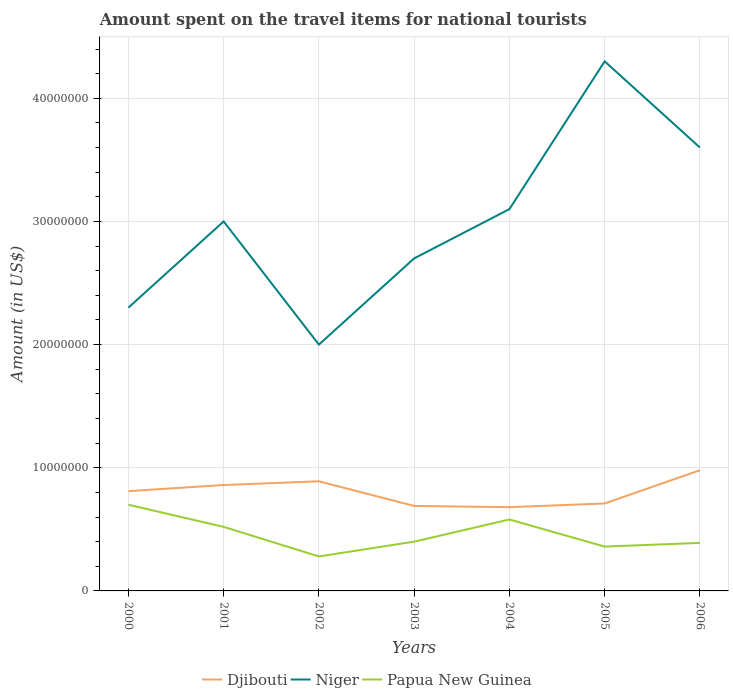Is the number of lines equal to the number of legend labels?
Give a very brief answer. Yes. In which year was the amount spent on the travel items for national tourists in Djibouti maximum?
Provide a short and direct response. 2004. What is the total amount spent on the travel items for national tourists in Djibouti in the graph?
Your response must be concise. -2.00e+05. What is the difference between the highest and the second highest amount spent on the travel items for national tourists in Djibouti?
Provide a short and direct response. 3.00e+06. What is the difference between the highest and the lowest amount spent on the travel items for national tourists in Niger?
Offer a very short reply. 3. How many lines are there?
Make the answer very short. 3. Does the graph contain any zero values?
Your response must be concise. No. Does the graph contain grids?
Provide a short and direct response. Yes. Where does the legend appear in the graph?
Offer a terse response. Bottom center. How are the legend labels stacked?
Your answer should be compact. Horizontal. What is the title of the graph?
Give a very brief answer. Amount spent on the travel items for national tourists. Does "Dominican Republic" appear as one of the legend labels in the graph?
Provide a short and direct response. No. What is the label or title of the X-axis?
Give a very brief answer. Years. What is the Amount (in US$) in Djibouti in 2000?
Provide a short and direct response. 8.10e+06. What is the Amount (in US$) of Niger in 2000?
Your response must be concise. 2.30e+07. What is the Amount (in US$) in Papua New Guinea in 2000?
Your answer should be very brief. 7.00e+06. What is the Amount (in US$) of Djibouti in 2001?
Ensure brevity in your answer.  8.60e+06. What is the Amount (in US$) in Niger in 2001?
Ensure brevity in your answer.  3.00e+07. What is the Amount (in US$) in Papua New Guinea in 2001?
Give a very brief answer. 5.20e+06. What is the Amount (in US$) of Djibouti in 2002?
Offer a very short reply. 8.90e+06. What is the Amount (in US$) of Niger in 2002?
Make the answer very short. 2.00e+07. What is the Amount (in US$) in Papua New Guinea in 2002?
Provide a succinct answer. 2.80e+06. What is the Amount (in US$) of Djibouti in 2003?
Make the answer very short. 6.90e+06. What is the Amount (in US$) in Niger in 2003?
Your answer should be very brief. 2.70e+07. What is the Amount (in US$) in Papua New Guinea in 2003?
Provide a short and direct response. 4.00e+06. What is the Amount (in US$) in Djibouti in 2004?
Keep it short and to the point. 6.80e+06. What is the Amount (in US$) of Niger in 2004?
Give a very brief answer. 3.10e+07. What is the Amount (in US$) in Papua New Guinea in 2004?
Your answer should be very brief. 5.80e+06. What is the Amount (in US$) of Djibouti in 2005?
Make the answer very short. 7.10e+06. What is the Amount (in US$) of Niger in 2005?
Make the answer very short. 4.30e+07. What is the Amount (in US$) in Papua New Guinea in 2005?
Give a very brief answer. 3.60e+06. What is the Amount (in US$) in Djibouti in 2006?
Your response must be concise. 9.80e+06. What is the Amount (in US$) in Niger in 2006?
Ensure brevity in your answer.  3.60e+07. What is the Amount (in US$) in Papua New Guinea in 2006?
Your response must be concise. 3.90e+06. Across all years, what is the maximum Amount (in US$) in Djibouti?
Offer a terse response. 9.80e+06. Across all years, what is the maximum Amount (in US$) of Niger?
Keep it short and to the point. 4.30e+07. Across all years, what is the minimum Amount (in US$) of Djibouti?
Your answer should be very brief. 6.80e+06. Across all years, what is the minimum Amount (in US$) in Niger?
Your answer should be compact. 2.00e+07. Across all years, what is the minimum Amount (in US$) in Papua New Guinea?
Ensure brevity in your answer.  2.80e+06. What is the total Amount (in US$) of Djibouti in the graph?
Your response must be concise. 5.62e+07. What is the total Amount (in US$) in Niger in the graph?
Offer a terse response. 2.10e+08. What is the total Amount (in US$) of Papua New Guinea in the graph?
Ensure brevity in your answer.  3.23e+07. What is the difference between the Amount (in US$) in Djibouti in 2000 and that in 2001?
Offer a very short reply. -5.00e+05. What is the difference between the Amount (in US$) of Niger in 2000 and that in 2001?
Your answer should be very brief. -7.00e+06. What is the difference between the Amount (in US$) in Papua New Guinea in 2000 and that in 2001?
Give a very brief answer. 1.80e+06. What is the difference between the Amount (in US$) of Djibouti in 2000 and that in 2002?
Keep it short and to the point. -8.00e+05. What is the difference between the Amount (in US$) in Papua New Guinea in 2000 and that in 2002?
Offer a terse response. 4.20e+06. What is the difference between the Amount (in US$) of Djibouti in 2000 and that in 2003?
Keep it short and to the point. 1.20e+06. What is the difference between the Amount (in US$) in Niger in 2000 and that in 2003?
Keep it short and to the point. -4.00e+06. What is the difference between the Amount (in US$) of Papua New Guinea in 2000 and that in 2003?
Offer a very short reply. 3.00e+06. What is the difference between the Amount (in US$) in Djibouti in 2000 and that in 2004?
Give a very brief answer. 1.30e+06. What is the difference between the Amount (in US$) in Niger in 2000 and that in 2004?
Your answer should be very brief. -8.00e+06. What is the difference between the Amount (in US$) of Papua New Guinea in 2000 and that in 2004?
Make the answer very short. 1.20e+06. What is the difference between the Amount (in US$) in Niger in 2000 and that in 2005?
Offer a very short reply. -2.00e+07. What is the difference between the Amount (in US$) in Papua New Guinea in 2000 and that in 2005?
Provide a succinct answer. 3.40e+06. What is the difference between the Amount (in US$) in Djibouti in 2000 and that in 2006?
Offer a terse response. -1.70e+06. What is the difference between the Amount (in US$) in Niger in 2000 and that in 2006?
Your response must be concise. -1.30e+07. What is the difference between the Amount (in US$) in Papua New Guinea in 2000 and that in 2006?
Ensure brevity in your answer.  3.10e+06. What is the difference between the Amount (in US$) in Papua New Guinea in 2001 and that in 2002?
Offer a terse response. 2.40e+06. What is the difference between the Amount (in US$) in Djibouti in 2001 and that in 2003?
Provide a succinct answer. 1.70e+06. What is the difference between the Amount (in US$) of Papua New Guinea in 2001 and that in 2003?
Offer a terse response. 1.20e+06. What is the difference between the Amount (in US$) in Djibouti in 2001 and that in 2004?
Offer a terse response. 1.80e+06. What is the difference between the Amount (in US$) in Niger in 2001 and that in 2004?
Keep it short and to the point. -1.00e+06. What is the difference between the Amount (in US$) in Papua New Guinea in 2001 and that in 2004?
Provide a short and direct response. -6.00e+05. What is the difference between the Amount (in US$) in Djibouti in 2001 and that in 2005?
Provide a short and direct response. 1.50e+06. What is the difference between the Amount (in US$) in Niger in 2001 and that in 2005?
Provide a short and direct response. -1.30e+07. What is the difference between the Amount (in US$) in Papua New Guinea in 2001 and that in 2005?
Provide a short and direct response. 1.60e+06. What is the difference between the Amount (in US$) of Djibouti in 2001 and that in 2006?
Make the answer very short. -1.20e+06. What is the difference between the Amount (in US$) in Niger in 2001 and that in 2006?
Ensure brevity in your answer.  -6.00e+06. What is the difference between the Amount (in US$) of Papua New Guinea in 2001 and that in 2006?
Ensure brevity in your answer.  1.30e+06. What is the difference between the Amount (in US$) in Djibouti in 2002 and that in 2003?
Provide a short and direct response. 2.00e+06. What is the difference between the Amount (in US$) of Niger in 2002 and that in 2003?
Keep it short and to the point. -7.00e+06. What is the difference between the Amount (in US$) of Papua New Guinea in 2002 and that in 2003?
Your answer should be very brief. -1.20e+06. What is the difference between the Amount (in US$) of Djibouti in 2002 and that in 2004?
Your response must be concise. 2.10e+06. What is the difference between the Amount (in US$) in Niger in 2002 and that in 2004?
Your answer should be very brief. -1.10e+07. What is the difference between the Amount (in US$) of Papua New Guinea in 2002 and that in 2004?
Provide a succinct answer. -3.00e+06. What is the difference between the Amount (in US$) of Djibouti in 2002 and that in 2005?
Your answer should be compact. 1.80e+06. What is the difference between the Amount (in US$) of Niger in 2002 and that in 2005?
Give a very brief answer. -2.30e+07. What is the difference between the Amount (in US$) of Papua New Guinea in 2002 and that in 2005?
Offer a terse response. -8.00e+05. What is the difference between the Amount (in US$) in Djibouti in 2002 and that in 2006?
Provide a succinct answer. -9.00e+05. What is the difference between the Amount (in US$) of Niger in 2002 and that in 2006?
Provide a succinct answer. -1.60e+07. What is the difference between the Amount (in US$) of Papua New Guinea in 2002 and that in 2006?
Ensure brevity in your answer.  -1.10e+06. What is the difference between the Amount (in US$) of Djibouti in 2003 and that in 2004?
Provide a succinct answer. 1.00e+05. What is the difference between the Amount (in US$) of Niger in 2003 and that in 2004?
Keep it short and to the point. -4.00e+06. What is the difference between the Amount (in US$) of Papua New Guinea in 2003 and that in 2004?
Ensure brevity in your answer.  -1.80e+06. What is the difference between the Amount (in US$) in Djibouti in 2003 and that in 2005?
Your answer should be compact. -2.00e+05. What is the difference between the Amount (in US$) of Niger in 2003 and that in 2005?
Provide a short and direct response. -1.60e+07. What is the difference between the Amount (in US$) in Papua New Guinea in 2003 and that in 2005?
Provide a short and direct response. 4.00e+05. What is the difference between the Amount (in US$) of Djibouti in 2003 and that in 2006?
Ensure brevity in your answer.  -2.90e+06. What is the difference between the Amount (in US$) of Niger in 2003 and that in 2006?
Your response must be concise. -9.00e+06. What is the difference between the Amount (in US$) in Papua New Guinea in 2003 and that in 2006?
Provide a succinct answer. 1.00e+05. What is the difference between the Amount (in US$) in Djibouti in 2004 and that in 2005?
Ensure brevity in your answer.  -3.00e+05. What is the difference between the Amount (in US$) of Niger in 2004 and that in 2005?
Ensure brevity in your answer.  -1.20e+07. What is the difference between the Amount (in US$) of Papua New Guinea in 2004 and that in 2005?
Make the answer very short. 2.20e+06. What is the difference between the Amount (in US$) of Niger in 2004 and that in 2006?
Your response must be concise. -5.00e+06. What is the difference between the Amount (in US$) in Papua New Guinea in 2004 and that in 2006?
Your answer should be very brief. 1.90e+06. What is the difference between the Amount (in US$) in Djibouti in 2005 and that in 2006?
Give a very brief answer. -2.70e+06. What is the difference between the Amount (in US$) of Djibouti in 2000 and the Amount (in US$) of Niger in 2001?
Ensure brevity in your answer.  -2.19e+07. What is the difference between the Amount (in US$) in Djibouti in 2000 and the Amount (in US$) in Papua New Guinea in 2001?
Your answer should be very brief. 2.90e+06. What is the difference between the Amount (in US$) in Niger in 2000 and the Amount (in US$) in Papua New Guinea in 2001?
Your answer should be compact. 1.78e+07. What is the difference between the Amount (in US$) of Djibouti in 2000 and the Amount (in US$) of Niger in 2002?
Keep it short and to the point. -1.19e+07. What is the difference between the Amount (in US$) in Djibouti in 2000 and the Amount (in US$) in Papua New Guinea in 2002?
Your answer should be very brief. 5.30e+06. What is the difference between the Amount (in US$) of Niger in 2000 and the Amount (in US$) of Papua New Guinea in 2002?
Ensure brevity in your answer.  2.02e+07. What is the difference between the Amount (in US$) in Djibouti in 2000 and the Amount (in US$) in Niger in 2003?
Give a very brief answer. -1.89e+07. What is the difference between the Amount (in US$) of Djibouti in 2000 and the Amount (in US$) of Papua New Guinea in 2003?
Your answer should be compact. 4.10e+06. What is the difference between the Amount (in US$) in Niger in 2000 and the Amount (in US$) in Papua New Guinea in 2003?
Keep it short and to the point. 1.90e+07. What is the difference between the Amount (in US$) in Djibouti in 2000 and the Amount (in US$) in Niger in 2004?
Your answer should be very brief. -2.29e+07. What is the difference between the Amount (in US$) in Djibouti in 2000 and the Amount (in US$) in Papua New Guinea in 2004?
Your answer should be compact. 2.30e+06. What is the difference between the Amount (in US$) in Niger in 2000 and the Amount (in US$) in Papua New Guinea in 2004?
Offer a very short reply. 1.72e+07. What is the difference between the Amount (in US$) of Djibouti in 2000 and the Amount (in US$) of Niger in 2005?
Your response must be concise. -3.49e+07. What is the difference between the Amount (in US$) of Djibouti in 2000 and the Amount (in US$) of Papua New Guinea in 2005?
Offer a very short reply. 4.50e+06. What is the difference between the Amount (in US$) of Niger in 2000 and the Amount (in US$) of Papua New Guinea in 2005?
Provide a short and direct response. 1.94e+07. What is the difference between the Amount (in US$) of Djibouti in 2000 and the Amount (in US$) of Niger in 2006?
Ensure brevity in your answer.  -2.79e+07. What is the difference between the Amount (in US$) in Djibouti in 2000 and the Amount (in US$) in Papua New Guinea in 2006?
Provide a short and direct response. 4.20e+06. What is the difference between the Amount (in US$) in Niger in 2000 and the Amount (in US$) in Papua New Guinea in 2006?
Give a very brief answer. 1.91e+07. What is the difference between the Amount (in US$) in Djibouti in 2001 and the Amount (in US$) in Niger in 2002?
Make the answer very short. -1.14e+07. What is the difference between the Amount (in US$) in Djibouti in 2001 and the Amount (in US$) in Papua New Guinea in 2002?
Your answer should be very brief. 5.80e+06. What is the difference between the Amount (in US$) of Niger in 2001 and the Amount (in US$) of Papua New Guinea in 2002?
Offer a terse response. 2.72e+07. What is the difference between the Amount (in US$) of Djibouti in 2001 and the Amount (in US$) of Niger in 2003?
Make the answer very short. -1.84e+07. What is the difference between the Amount (in US$) of Djibouti in 2001 and the Amount (in US$) of Papua New Guinea in 2003?
Your response must be concise. 4.60e+06. What is the difference between the Amount (in US$) of Niger in 2001 and the Amount (in US$) of Papua New Guinea in 2003?
Offer a very short reply. 2.60e+07. What is the difference between the Amount (in US$) of Djibouti in 2001 and the Amount (in US$) of Niger in 2004?
Offer a terse response. -2.24e+07. What is the difference between the Amount (in US$) of Djibouti in 2001 and the Amount (in US$) of Papua New Guinea in 2004?
Make the answer very short. 2.80e+06. What is the difference between the Amount (in US$) in Niger in 2001 and the Amount (in US$) in Papua New Guinea in 2004?
Your answer should be very brief. 2.42e+07. What is the difference between the Amount (in US$) in Djibouti in 2001 and the Amount (in US$) in Niger in 2005?
Keep it short and to the point. -3.44e+07. What is the difference between the Amount (in US$) in Niger in 2001 and the Amount (in US$) in Papua New Guinea in 2005?
Provide a short and direct response. 2.64e+07. What is the difference between the Amount (in US$) in Djibouti in 2001 and the Amount (in US$) in Niger in 2006?
Offer a terse response. -2.74e+07. What is the difference between the Amount (in US$) of Djibouti in 2001 and the Amount (in US$) of Papua New Guinea in 2006?
Your answer should be compact. 4.70e+06. What is the difference between the Amount (in US$) of Niger in 2001 and the Amount (in US$) of Papua New Guinea in 2006?
Make the answer very short. 2.61e+07. What is the difference between the Amount (in US$) of Djibouti in 2002 and the Amount (in US$) of Niger in 2003?
Make the answer very short. -1.81e+07. What is the difference between the Amount (in US$) of Djibouti in 2002 and the Amount (in US$) of Papua New Guinea in 2003?
Ensure brevity in your answer.  4.90e+06. What is the difference between the Amount (in US$) in Niger in 2002 and the Amount (in US$) in Papua New Guinea in 2003?
Your answer should be compact. 1.60e+07. What is the difference between the Amount (in US$) of Djibouti in 2002 and the Amount (in US$) of Niger in 2004?
Offer a very short reply. -2.21e+07. What is the difference between the Amount (in US$) of Djibouti in 2002 and the Amount (in US$) of Papua New Guinea in 2004?
Keep it short and to the point. 3.10e+06. What is the difference between the Amount (in US$) of Niger in 2002 and the Amount (in US$) of Papua New Guinea in 2004?
Your answer should be compact. 1.42e+07. What is the difference between the Amount (in US$) of Djibouti in 2002 and the Amount (in US$) of Niger in 2005?
Provide a succinct answer. -3.41e+07. What is the difference between the Amount (in US$) of Djibouti in 2002 and the Amount (in US$) of Papua New Guinea in 2005?
Provide a short and direct response. 5.30e+06. What is the difference between the Amount (in US$) in Niger in 2002 and the Amount (in US$) in Papua New Guinea in 2005?
Provide a succinct answer. 1.64e+07. What is the difference between the Amount (in US$) of Djibouti in 2002 and the Amount (in US$) of Niger in 2006?
Keep it short and to the point. -2.71e+07. What is the difference between the Amount (in US$) in Djibouti in 2002 and the Amount (in US$) in Papua New Guinea in 2006?
Provide a short and direct response. 5.00e+06. What is the difference between the Amount (in US$) in Niger in 2002 and the Amount (in US$) in Papua New Guinea in 2006?
Offer a terse response. 1.61e+07. What is the difference between the Amount (in US$) of Djibouti in 2003 and the Amount (in US$) of Niger in 2004?
Your answer should be compact. -2.41e+07. What is the difference between the Amount (in US$) in Djibouti in 2003 and the Amount (in US$) in Papua New Guinea in 2004?
Your answer should be compact. 1.10e+06. What is the difference between the Amount (in US$) of Niger in 2003 and the Amount (in US$) of Papua New Guinea in 2004?
Ensure brevity in your answer.  2.12e+07. What is the difference between the Amount (in US$) of Djibouti in 2003 and the Amount (in US$) of Niger in 2005?
Your answer should be very brief. -3.61e+07. What is the difference between the Amount (in US$) in Djibouti in 2003 and the Amount (in US$) in Papua New Guinea in 2005?
Provide a short and direct response. 3.30e+06. What is the difference between the Amount (in US$) of Niger in 2003 and the Amount (in US$) of Papua New Guinea in 2005?
Give a very brief answer. 2.34e+07. What is the difference between the Amount (in US$) in Djibouti in 2003 and the Amount (in US$) in Niger in 2006?
Offer a very short reply. -2.91e+07. What is the difference between the Amount (in US$) in Niger in 2003 and the Amount (in US$) in Papua New Guinea in 2006?
Offer a terse response. 2.31e+07. What is the difference between the Amount (in US$) in Djibouti in 2004 and the Amount (in US$) in Niger in 2005?
Offer a terse response. -3.62e+07. What is the difference between the Amount (in US$) of Djibouti in 2004 and the Amount (in US$) of Papua New Guinea in 2005?
Your answer should be compact. 3.20e+06. What is the difference between the Amount (in US$) in Niger in 2004 and the Amount (in US$) in Papua New Guinea in 2005?
Your answer should be very brief. 2.74e+07. What is the difference between the Amount (in US$) in Djibouti in 2004 and the Amount (in US$) in Niger in 2006?
Your answer should be compact. -2.92e+07. What is the difference between the Amount (in US$) of Djibouti in 2004 and the Amount (in US$) of Papua New Guinea in 2006?
Ensure brevity in your answer.  2.90e+06. What is the difference between the Amount (in US$) of Niger in 2004 and the Amount (in US$) of Papua New Guinea in 2006?
Offer a terse response. 2.71e+07. What is the difference between the Amount (in US$) in Djibouti in 2005 and the Amount (in US$) in Niger in 2006?
Provide a succinct answer. -2.89e+07. What is the difference between the Amount (in US$) of Djibouti in 2005 and the Amount (in US$) of Papua New Guinea in 2006?
Make the answer very short. 3.20e+06. What is the difference between the Amount (in US$) of Niger in 2005 and the Amount (in US$) of Papua New Guinea in 2006?
Provide a short and direct response. 3.91e+07. What is the average Amount (in US$) of Djibouti per year?
Keep it short and to the point. 8.03e+06. What is the average Amount (in US$) of Niger per year?
Offer a terse response. 3.00e+07. What is the average Amount (in US$) of Papua New Guinea per year?
Provide a succinct answer. 4.61e+06. In the year 2000, what is the difference between the Amount (in US$) of Djibouti and Amount (in US$) of Niger?
Keep it short and to the point. -1.49e+07. In the year 2000, what is the difference between the Amount (in US$) in Djibouti and Amount (in US$) in Papua New Guinea?
Offer a very short reply. 1.10e+06. In the year 2000, what is the difference between the Amount (in US$) in Niger and Amount (in US$) in Papua New Guinea?
Offer a very short reply. 1.60e+07. In the year 2001, what is the difference between the Amount (in US$) of Djibouti and Amount (in US$) of Niger?
Ensure brevity in your answer.  -2.14e+07. In the year 2001, what is the difference between the Amount (in US$) in Djibouti and Amount (in US$) in Papua New Guinea?
Provide a short and direct response. 3.40e+06. In the year 2001, what is the difference between the Amount (in US$) in Niger and Amount (in US$) in Papua New Guinea?
Offer a terse response. 2.48e+07. In the year 2002, what is the difference between the Amount (in US$) of Djibouti and Amount (in US$) of Niger?
Your answer should be very brief. -1.11e+07. In the year 2002, what is the difference between the Amount (in US$) of Djibouti and Amount (in US$) of Papua New Guinea?
Give a very brief answer. 6.10e+06. In the year 2002, what is the difference between the Amount (in US$) in Niger and Amount (in US$) in Papua New Guinea?
Your response must be concise. 1.72e+07. In the year 2003, what is the difference between the Amount (in US$) of Djibouti and Amount (in US$) of Niger?
Make the answer very short. -2.01e+07. In the year 2003, what is the difference between the Amount (in US$) in Djibouti and Amount (in US$) in Papua New Guinea?
Your response must be concise. 2.90e+06. In the year 2003, what is the difference between the Amount (in US$) in Niger and Amount (in US$) in Papua New Guinea?
Make the answer very short. 2.30e+07. In the year 2004, what is the difference between the Amount (in US$) of Djibouti and Amount (in US$) of Niger?
Make the answer very short. -2.42e+07. In the year 2004, what is the difference between the Amount (in US$) of Djibouti and Amount (in US$) of Papua New Guinea?
Your answer should be compact. 1.00e+06. In the year 2004, what is the difference between the Amount (in US$) of Niger and Amount (in US$) of Papua New Guinea?
Your answer should be compact. 2.52e+07. In the year 2005, what is the difference between the Amount (in US$) in Djibouti and Amount (in US$) in Niger?
Provide a succinct answer. -3.59e+07. In the year 2005, what is the difference between the Amount (in US$) of Djibouti and Amount (in US$) of Papua New Guinea?
Give a very brief answer. 3.50e+06. In the year 2005, what is the difference between the Amount (in US$) in Niger and Amount (in US$) in Papua New Guinea?
Make the answer very short. 3.94e+07. In the year 2006, what is the difference between the Amount (in US$) in Djibouti and Amount (in US$) in Niger?
Offer a terse response. -2.62e+07. In the year 2006, what is the difference between the Amount (in US$) of Djibouti and Amount (in US$) of Papua New Guinea?
Give a very brief answer. 5.90e+06. In the year 2006, what is the difference between the Amount (in US$) in Niger and Amount (in US$) in Papua New Guinea?
Provide a succinct answer. 3.21e+07. What is the ratio of the Amount (in US$) in Djibouti in 2000 to that in 2001?
Ensure brevity in your answer.  0.94. What is the ratio of the Amount (in US$) of Niger in 2000 to that in 2001?
Your response must be concise. 0.77. What is the ratio of the Amount (in US$) of Papua New Guinea in 2000 to that in 2001?
Your answer should be compact. 1.35. What is the ratio of the Amount (in US$) in Djibouti in 2000 to that in 2002?
Offer a terse response. 0.91. What is the ratio of the Amount (in US$) of Niger in 2000 to that in 2002?
Ensure brevity in your answer.  1.15. What is the ratio of the Amount (in US$) in Papua New Guinea in 2000 to that in 2002?
Offer a terse response. 2.5. What is the ratio of the Amount (in US$) in Djibouti in 2000 to that in 2003?
Your answer should be compact. 1.17. What is the ratio of the Amount (in US$) of Niger in 2000 to that in 2003?
Your answer should be compact. 0.85. What is the ratio of the Amount (in US$) of Papua New Guinea in 2000 to that in 2003?
Provide a short and direct response. 1.75. What is the ratio of the Amount (in US$) in Djibouti in 2000 to that in 2004?
Your response must be concise. 1.19. What is the ratio of the Amount (in US$) of Niger in 2000 to that in 2004?
Your response must be concise. 0.74. What is the ratio of the Amount (in US$) in Papua New Guinea in 2000 to that in 2004?
Provide a short and direct response. 1.21. What is the ratio of the Amount (in US$) of Djibouti in 2000 to that in 2005?
Make the answer very short. 1.14. What is the ratio of the Amount (in US$) of Niger in 2000 to that in 2005?
Keep it short and to the point. 0.53. What is the ratio of the Amount (in US$) of Papua New Guinea in 2000 to that in 2005?
Keep it short and to the point. 1.94. What is the ratio of the Amount (in US$) of Djibouti in 2000 to that in 2006?
Ensure brevity in your answer.  0.83. What is the ratio of the Amount (in US$) of Niger in 2000 to that in 2006?
Your answer should be compact. 0.64. What is the ratio of the Amount (in US$) of Papua New Guinea in 2000 to that in 2006?
Offer a terse response. 1.79. What is the ratio of the Amount (in US$) of Djibouti in 2001 to that in 2002?
Keep it short and to the point. 0.97. What is the ratio of the Amount (in US$) of Papua New Guinea in 2001 to that in 2002?
Make the answer very short. 1.86. What is the ratio of the Amount (in US$) of Djibouti in 2001 to that in 2003?
Ensure brevity in your answer.  1.25. What is the ratio of the Amount (in US$) in Niger in 2001 to that in 2003?
Give a very brief answer. 1.11. What is the ratio of the Amount (in US$) in Papua New Guinea in 2001 to that in 2003?
Your answer should be compact. 1.3. What is the ratio of the Amount (in US$) of Djibouti in 2001 to that in 2004?
Keep it short and to the point. 1.26. What is the ratio of the Amount (in US$) in Niger in 2001 to that in 2004?
Give a very brief answer. 0.97. What is the ratio of the Amount (in US$) of Papua New Guinea in 2001 to that in 2004?
Your response must be concise. 0.9. What is the ratio of the Amount (in US$) of Djibouti in 2001 to that in 2005?
Offer a very short reply. 1.21. What is the ratio of the Amount (in US$) of Niger in 2001 to that in 2005?
Offer a very short reply. 0.7. What is the ratio of the Amount (in US$) in Papua New Guinea in 2001 to that in 2005?
Your answer should be very brief. 1.44. What is the ratio of the Amount (in US$) in Djibouti in 2001 to that in 2006?
Provide a succinct answer. 0.88. What is the ratio of the Amount (in US$) of Djibouti in 2002 to that in 2003?
Provide a succinct answer. 1.29. What is the ratio of the Amount (in US$) in Niger in 2002 to that in 2003?
Provide a succinct answer. 0.74. What is the ratio of the Amount (in US$) of Djibouti in 2002 to that in 2004?
Give a very brief answer. 1.31. What is the ratio of the Amount (in US$) in Niger in 2002 to that in 2004?
Your answer should be very brief. 0.65. What is the ratio of the Amount (in US$) of Papua New Guinea in 2002 to that in 2004?
Your answer should be compact. 0.48. What is the ratio of the Amount (in US$) of Djibouti in 2002 to that in 2005?
Make the answer very short. 1.25. What is the ratio of the Amount (in US$) of Niger in 2002 to that in 2005?
Your answer should be very brief. 0.47. What is the ratio of the Amount (in US$) of Papua New Guinea in 2002 to that in 2005?
Provide a succinct answer. 0.78. What is the ratio of the Amount (in US$) of Djibouti in 2002 to that in 2006?
Offer a terse response. 0.91. What is the ratio of the Amount (in US$) in Niger in 2002 to that in 2006?
Make the answer very short. 0.56. What is the ratio of the Amount (in US$) in Papua New Guinea in 2002 to that in 2006?
Your response must be concise. 0.72. What is the ratio of the Amount (in US$) of Djibouti in 2003 to that in 2004?
Offer a very short reply. 1.01. What is the ratio of the Amount (in US$) of Niger in 2003 to that in 2004?
Offer a terse response. 0.87. What is the ratio of the Amount (in US$) of Papua New Guinea in 2003 to that in 2004?
Keep it short and to the point. 0.69. What is the ratio of the Amount (in US$) in Djibouti in 2003 to that in 2005?
Your answer should be compact. 0.97. What is the ratio of the Amount (in US$) in Niger in 2003 to that in 2005?
Provide a succinct answer. 0.63. What is the ratio of the Amount (in US$) of Djibouti in 2003 to that in 2006?
Make the answer very short. 0.7. What is the ratio of the Amount (in US$) of Papua New Guinea in 2003 to that in 2006?
Make the answer very short. 1.03. What is the ratio of the Amount (in US$) of Djibouti in 2004 to that in 2005?
Make the answer very short. 0.96. What is the ratio of the Amount (in US$) of Niger in 2004 to that in 2005?
Offer a very short reply. 0.72. What is the ratio of the Amount (in US$) in Papua New Guinea in 2004 to that in 2005?
Offer a very short reply. 1.61. What is the ratio of the Amount (in US$) of Djibouti in 2004 to that in 2006?
Provide a short and direct response. 0.69. What is the ratio of the Amount (in US$) of Niger in 2004 to that in 2006?
Your answer should be very brief. 0.86. What is the ratio of the Amount (in US$) of Papua New Guinea in 2004 to that in 2006?
Give a very brief answer. 1.49. What is the ratio of the Amount (in US$) in Djibouti in 2005 to that in 2006?
Provide a short and direct response. 0.72. What is the ratio of the Amount (in US$) of Niger in 2005 to that in 2006?
Provide a short and direct response. 1.19. What is the difference between the highest and the second highest Amount (in US$) in Djibouti?
Give a very brief answer. 9.00e+05. What is the difference between the highest and the second highest Amount (in US$) in Niger?
Your answer should be very brief. 7.00e+06. What is the difference between the highest and the second highest Amount (in US$) in Papua New Guinea?
Give a very brief answer. 1.20e+06. What is the difference between the highest and the lowest Amount (in US$) of Djibouti?
Provide a short and direct response. 3.00e+06. What is the difference between the highest and the lowest Amount (in US$) in Niger?
Your response must be concise. 2.30e+07. What is the difference between the highest and the lowest Amount (in US$) in Papua New Guinea?
Your answer should be very brief. 4.20e+06. 